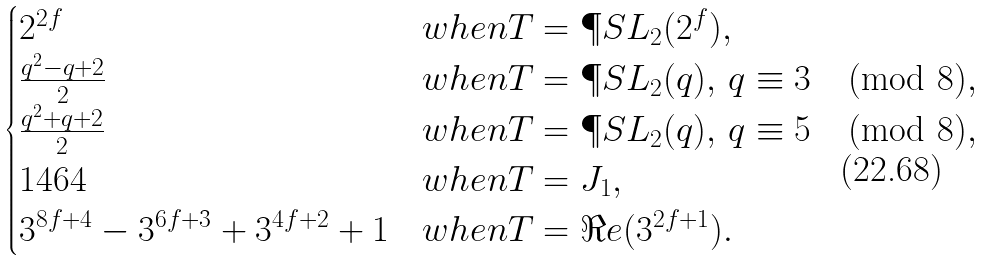<formula> <loc_0><loc_0><loc_500><loc_500>\begin{cases} 2 ^ { 2 f } & w h e n T = \P S L _ { 2 } ( 2 ^ { f } ) , \\ \frac { q ^ { 2 } - q + 2 } { 2 } & w h e n T = \P S L _ { 2 } ( q ) , \, q \equiv 3 \pmod { 8 } , \\ \frac { q ^ { 2 } + q + 2 } { 2 } & w h e n T = \P S L _ { 2 } ( q ) , \, q \equiv 5 \pmod { 8 } , \\ 1 4 6 4 & w h e n T = J _ { 1 } , \\ 3 ^ { 8 f + 4 } - 3 ^ { 6 f + 3 } + 3 ^ { 4 f + 2 } + 1 & w h e n T = \Re e ( 3 ^ { 2 f + 1 } ) . \end{cases}</formula> 